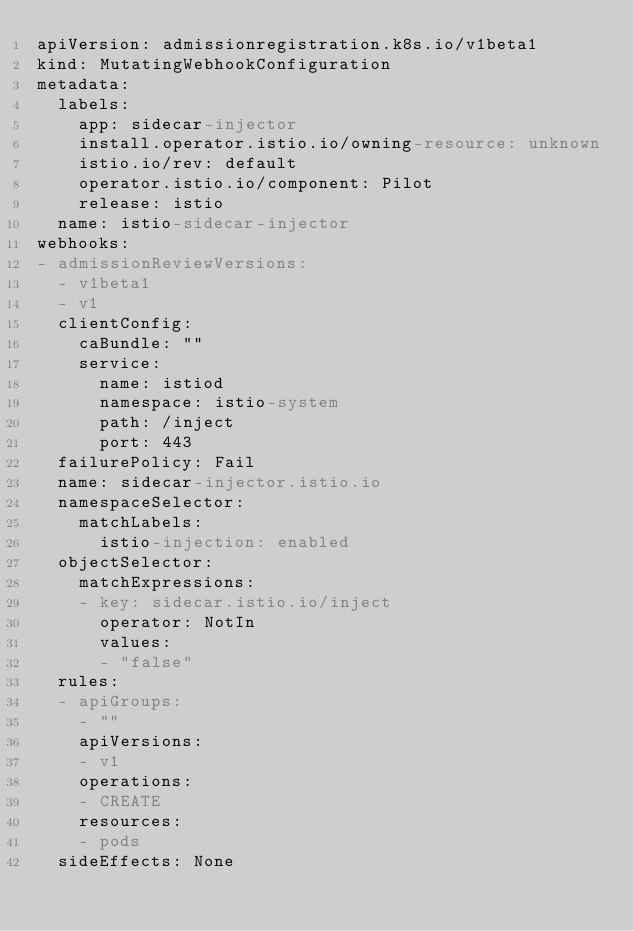Convert code to text. <code><loc_0><loc_0><loc_500><loc_500><_YAML_>apiVersion: admissionregistration.k8s.io/v1beta1
kind: MutatingWebhookConfiguration
metadata:
  labels:
    app: sidecar-injector
    install.operator.istio.io/owning-resource: unknown
    istio.io/rev: default
    operator.istio.io/component: Pilot
    release: istio
  name: istio-sidecar-injector
webhooks:
- admissionReviewVersions:
  - v1beta1
  - v1
  clientConfig:
    caBundle: ""
    service:
      name: istiod
      namespace: istio-system
      path: /inject
      port: 443
  failurePolicy: Fail
  name: sidecar-injector.istio.io
  namespaceSelector:
    matchLabels:
      istio-injection: enabled
  objectSelector:
    matchExpressions:
    - key: sidecar.istio.io/inject
      operator: NotIn
      values:
      - "false"
  rules:
  - apiGroups:
    - ""
    apiVersions:
    - v1
    operations:
    - CREATE
    resources:
    - pods
  sideEffects: None
</code> 